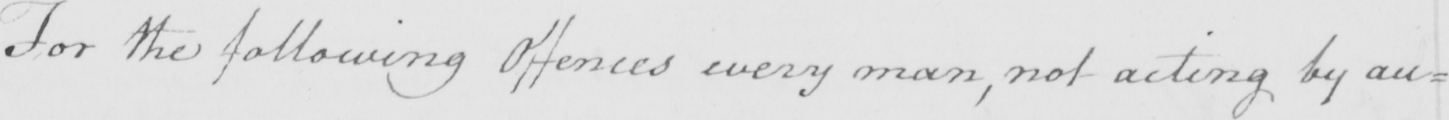Please provide the text content of this handwritten line. For the following Offences every man , not acting by au= 